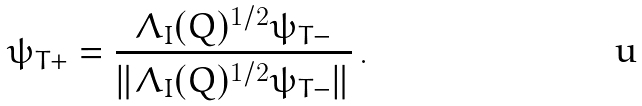Convert formula to latex. <formula><loc_0><loc_0><loc_500><loc_500>\psi _ { T + } = \frac { \Lambda _ { I } ( Q ) ^ { 1 / 2 } \psi _ { T - } } { \| \Lambda _ { I } ( Q ) ^ { 1 / 2 } \psi _ { T - } \| } \, .</formula> 